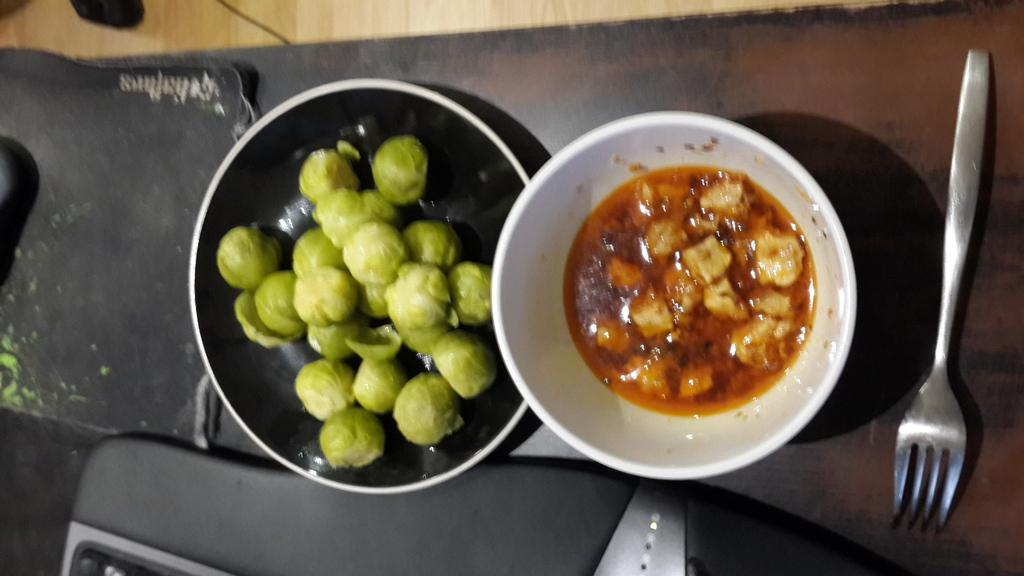What type of food is in the bowl in the image? There is a food item in the bowl, and it is green in color. What utensil is placed beside the bowl? There is a spoon beside the bowl. What type of cork can be seen floating in the bowl? There is no cork present in the bowl; it contains a green food item. What type of wilderness can be seen in the background of the image? There is no wilderness visible in the image; it only shows a bowl with a green food item and a spoon beside it. 